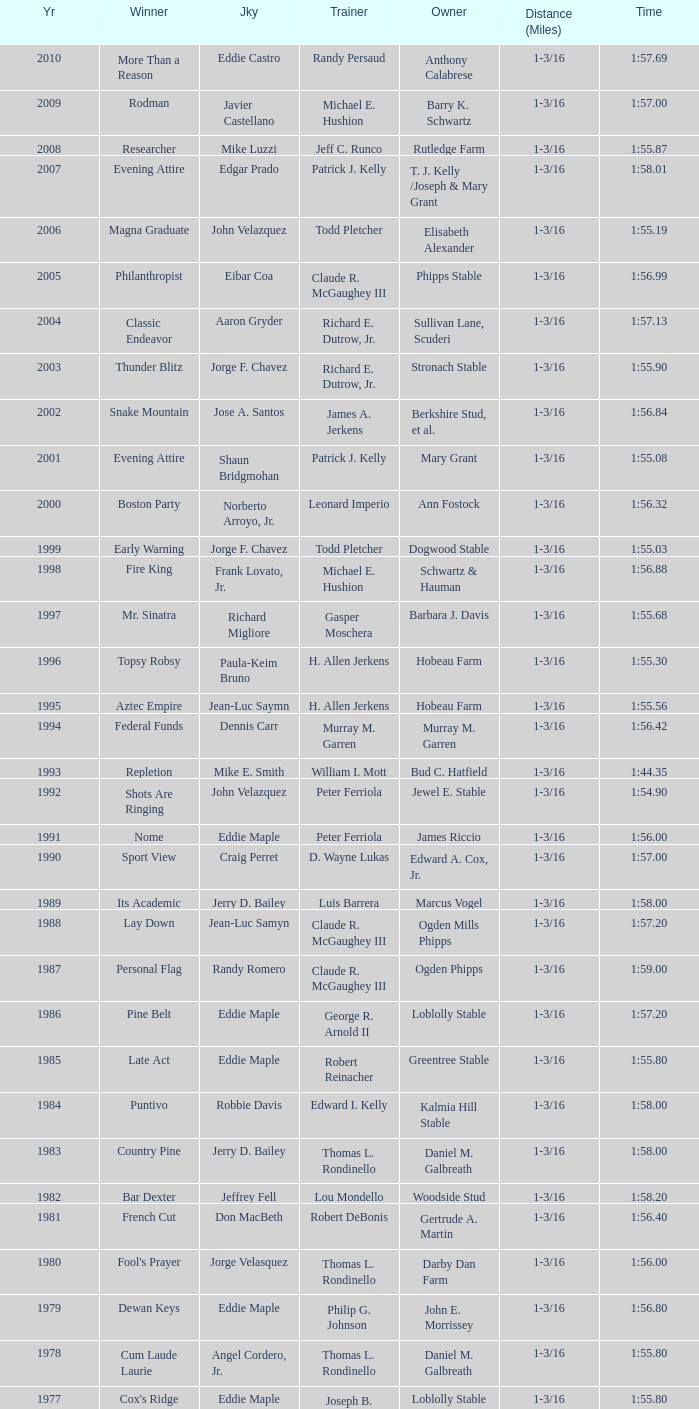When the winner was No Race in a year after 1909, what was the distance? 1 mile, 1 mile, 1 mile. 